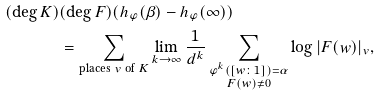<formula> <loc_0><loc_0><loc_500><loc_500>( \deg K ) & ( \deg F ) ( h _ { \varphi } ( \beta ) - h _ { \varphi } ( \infty ) ) \\ & = \sum _ { \text {places $v$ of $K$} } \lim _ { { k } \to \infty } \frac { 1 } { d ^ { k } } \sum _ { \substack { \varphi ^ { k } ( [ w \colon 1 ] ) = \alpha \\ F ( w ) \not = 0 } } \log | F ( w ) | _ { v } ,</formula> 